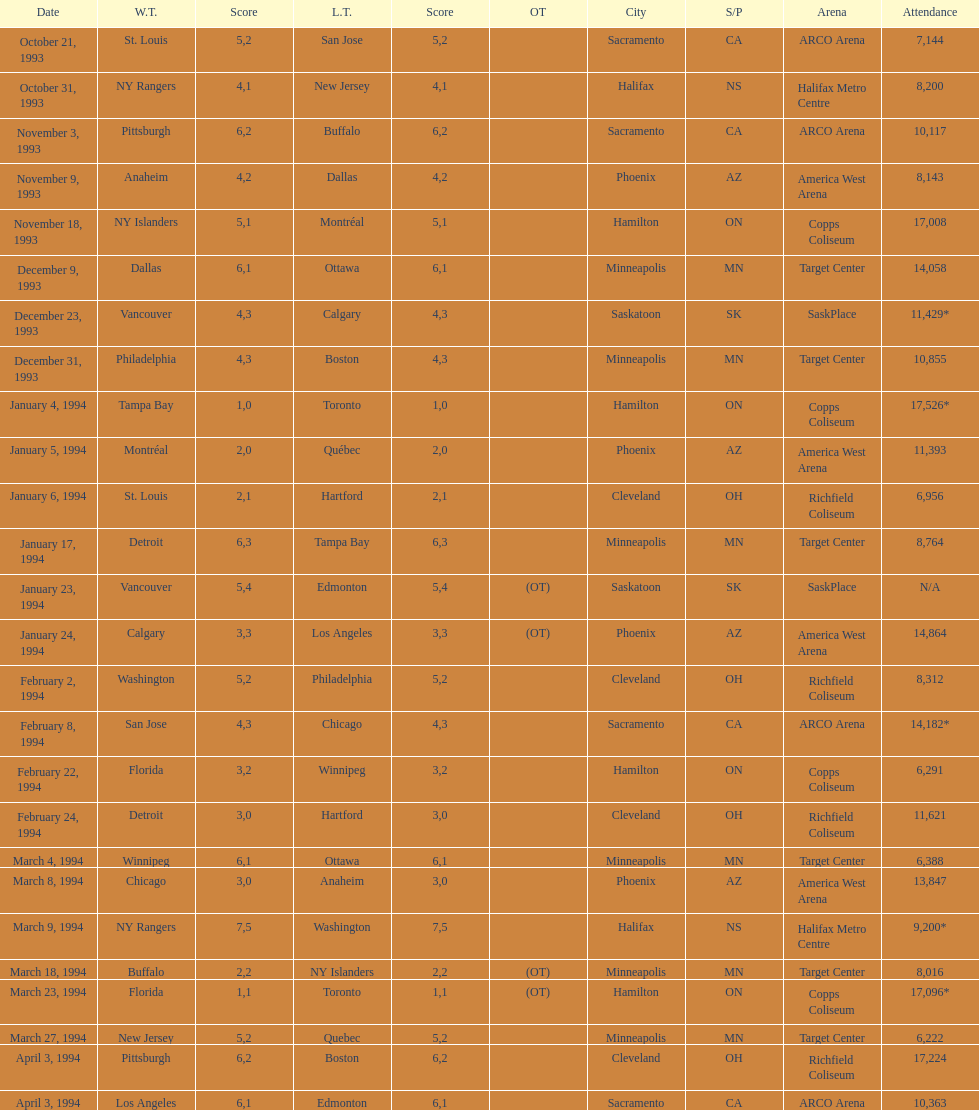Which gathering had more attendees, january 24, 1994, or december 23, 1993? January 4, 1994. 